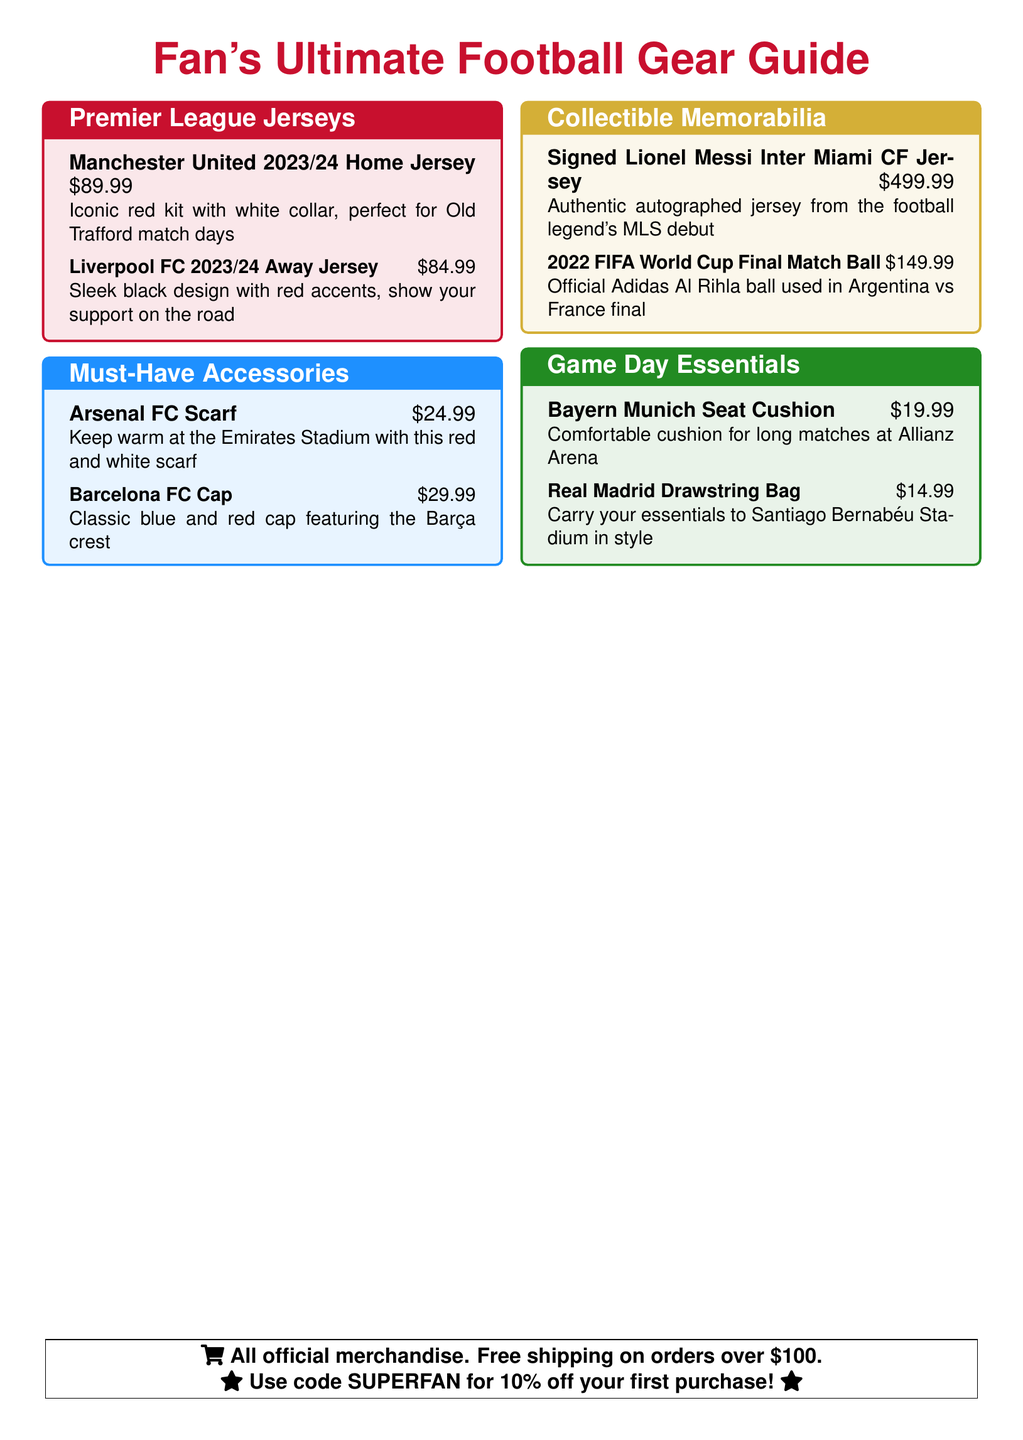What is the price of the Manchester United 2023/24 Home Jersey? The price is listed next to the jersey name in the document.
Answer: $89.99 Which accessory has a price of $24.99? The document shows the price of each accessory under their names.
Answer: Arsenal FC Scarf What color is the Liverpool FC 2023/24 Away Jersey? The document describes the color of the jersey in its details.
Answer: Black with red accents What is the price of the Signed Lionel Messi Inter Miami CF Jersey? The price is stated next to the memorabilia item in the document.
Answer: $499.99 Which team’s drawstring bag is featured in the catalog? The document specifies the team associated with the drawstring bag as part of the product description.
Answer: Real Madrid What type of product is the Bayern Munich Seat Cushion? The document categorizes products into specific types, and this one is listed under Game Day Essentials.
Answer: Cushion What discount code is provided for the first purchase? The document mentions the discount code for first-time purchases.
Answer: SUPERFAN How many jerseys are listed under Premier League Jerseys? The document includes a count of items within the specified category of jerseys.
Answer: 2 